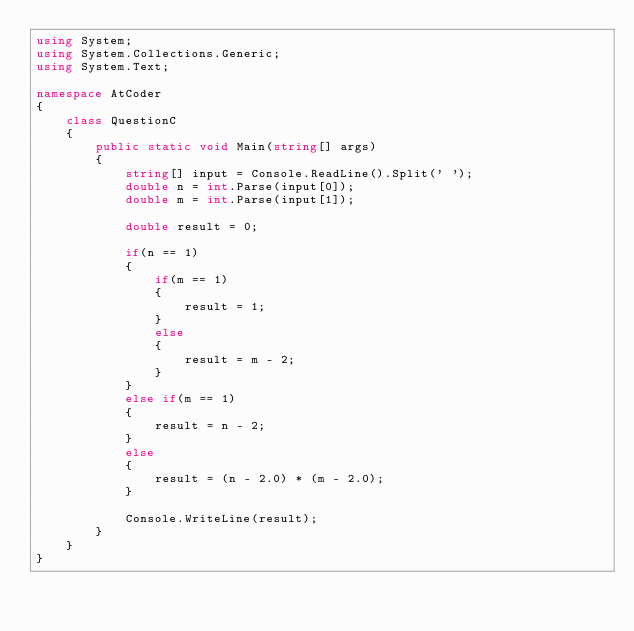Convert code to text. <code><loc_0><loc_0><loc_500><loc_500><_C#_>using System;
using System.Collections.Generic;
using System.Text;

namespace AtCoder
{
    class QuestionC
    {
        public static void Main(string[] args)
        {
            string[] input = Console.ReadLine().Split(' ');
            double n = int.Parse(input[0]);
            double m = int.Parse(input[1]);

            double result = 0;

            if(n == 1)
            {
                if(m == 1)
                {
                    result = 1;
                }
                else
                {
                    result = m - 2;
                }
            }
            else if(m == 1)
            {
                result = n - 2;
            }
            else
            {
                result = (n - 2.0) * (m - 2.0);
            }

            Console.WriteLine(result);
        }
    }
}
</code> 